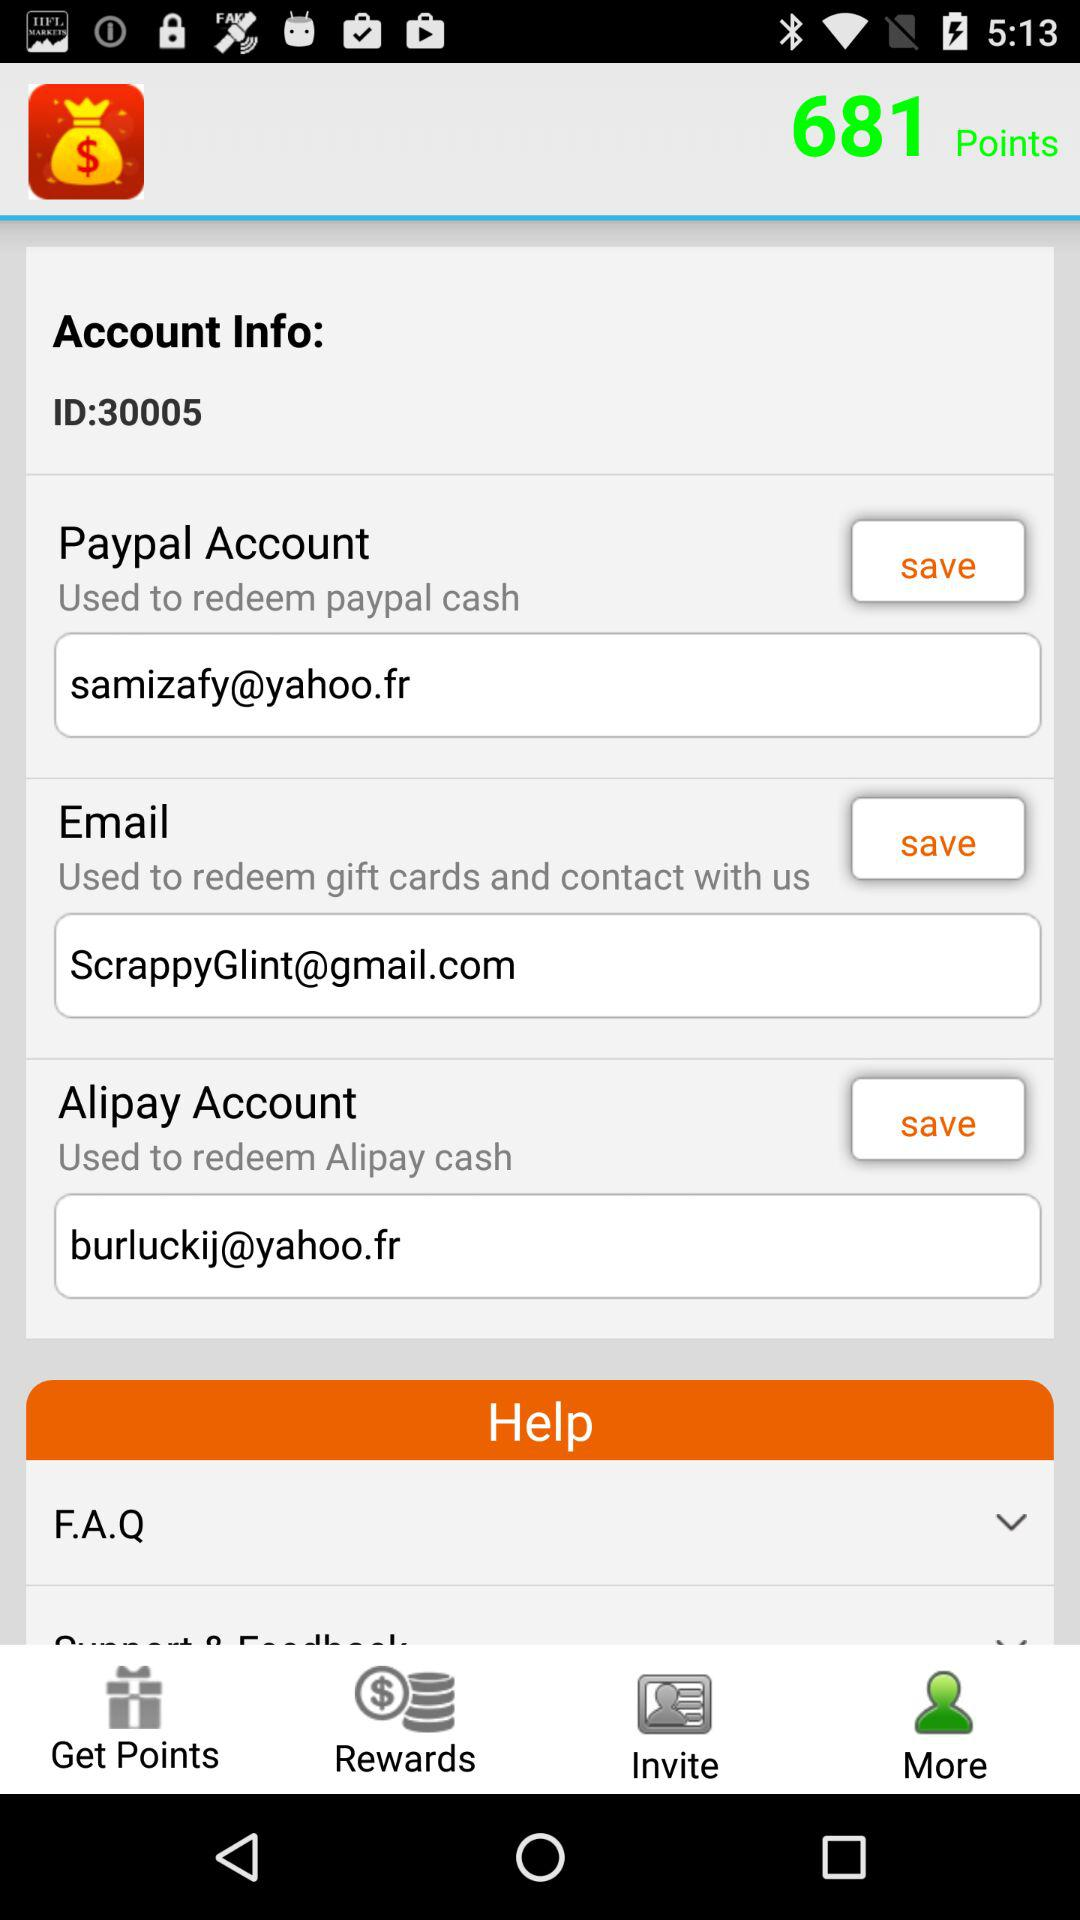What is the ID? The ID is 30005. 